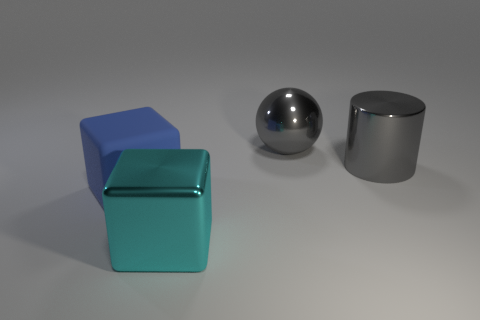What can you infer about the lighting and shadows in the scene? The lighting appears to be coming from the upper left, given the direction of the shadows cast by each object. Each object casts a soft-edged shadow to the right, suggesting a diffused light source in the environment. 